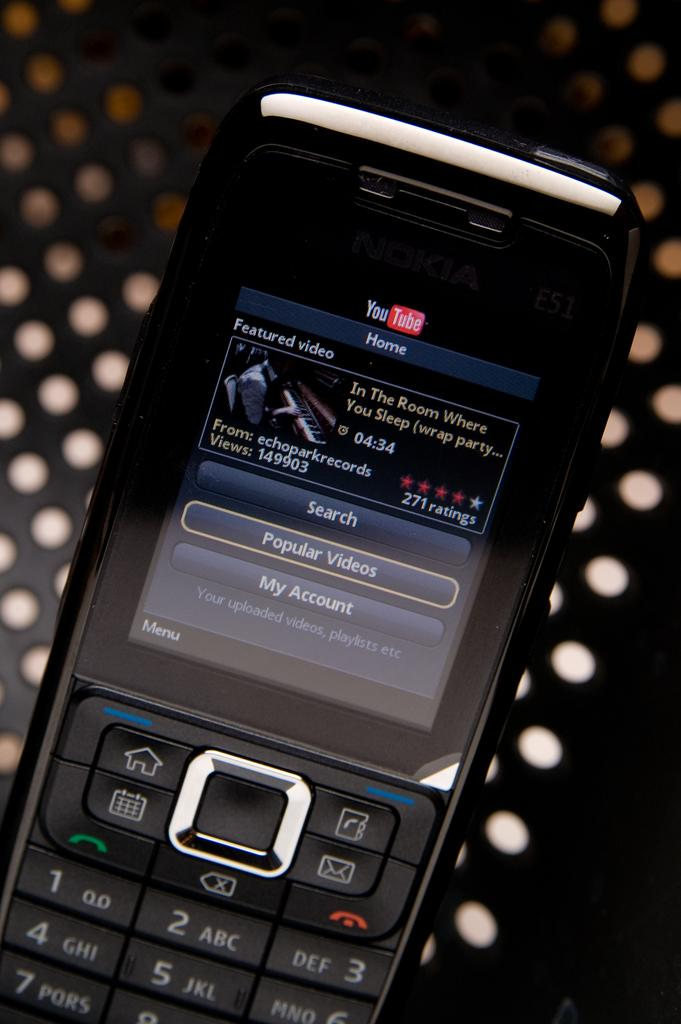Provide a one-sentence caption for the provided image. A black phone has a YouTube video pulled up of Echo Park Records "In The Room Where You Sleep". 